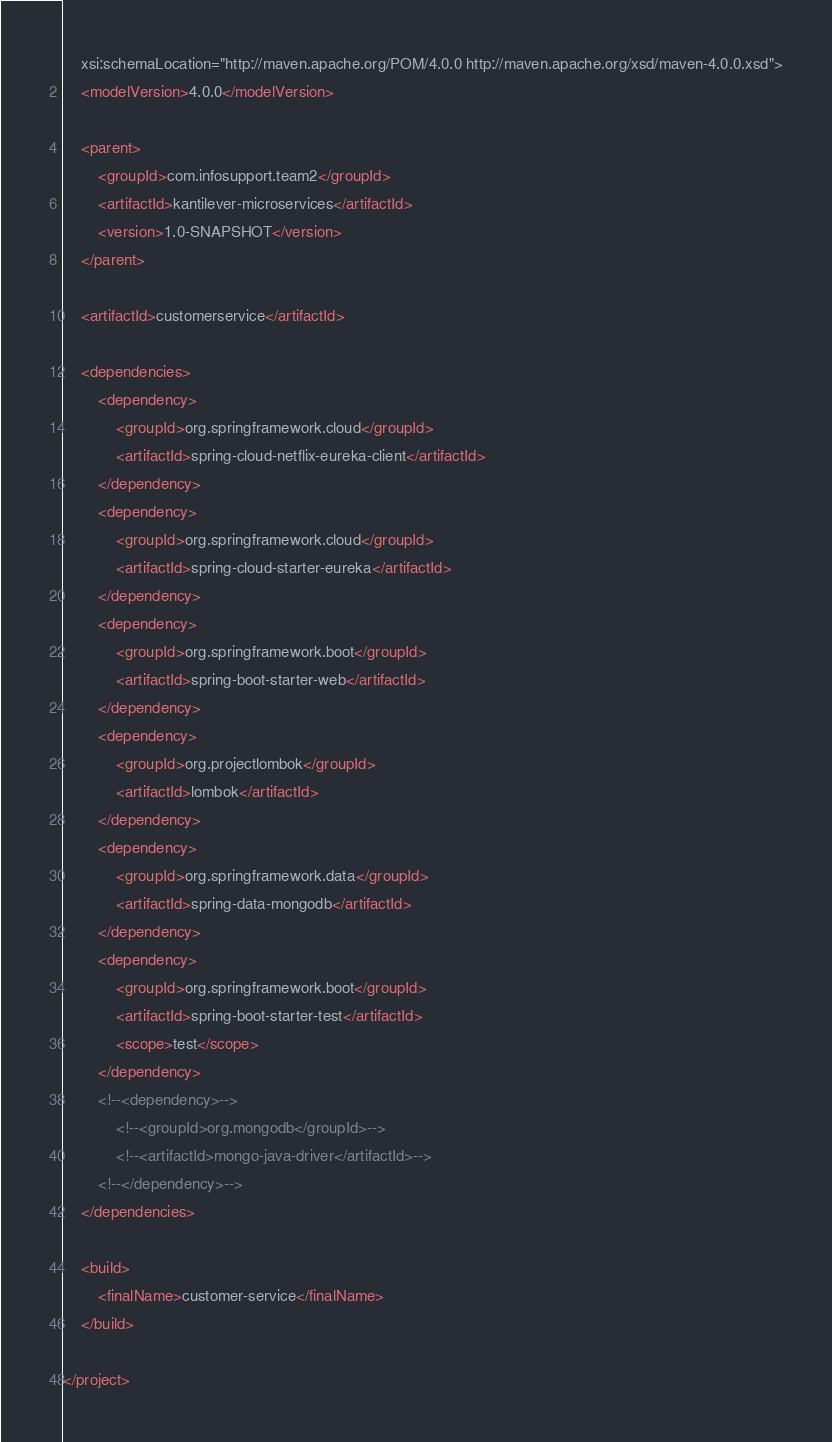<code> <loc_0><loc_0><loc_500><loc_500><_XML_>	xsi:schemaLocation="http://maven.apache.org/POM/4.0.0 http://maven.apache.org/xsd/maven-4.0.0.xsd">
	<modelVersion>4.0.0</modelVersion>

	<parent>
		<groupId>com.infosupport.team2</groupId>
		<artifactId>kantilever-microservices</artifactId>
		<version>1.0-SNAPSHOT</version>
	</parent>

	<artifactId>customerservice</artifactId>

	<dependencies>
        <dependency>
            <groupId>org.springframework.cloud</groupId>
            <artifactId>spring-cloud-netflix-eureka-client</artifactId>
        </dependency>
		<dependency>
			<groupId>org.springframework.cloud</groupId>
			<artifactId>spring-cloud-starter-eureka</artifactId>
		</dependency>
		<dependency>
			<groupId>org.springframework.boot</groupId>
			<artifactId>spring-boot-starter-web</artifactId>
		</dependency>
		<dependency>
			<groupId>org.projectlombok</groupId>
			<artifactId>lombok</artifactId>
		</dependency>
		<dependency>
			<groupId>org.springframework.data</groupId>
			<artifactId>spring-data-mongodb</artifactId>
		</dependency>
		<dependency>
			<groupId>org.springframework.boot</groupId>
			<artifactId>spring-boot-starter-test</artifactId>
			<scope>test</scope>
		</dependency>
		<!--<dependency>-->
			<!--<groupId>org.mongodb</groupId>-->
			<!--<artifactId>mongo-java-driver</artifactId>-->
		<!--</dependency>-->
	</dependencies>

	<build>
		<finalName>customer-service</finalName>
	</build>

</project>
</code> 